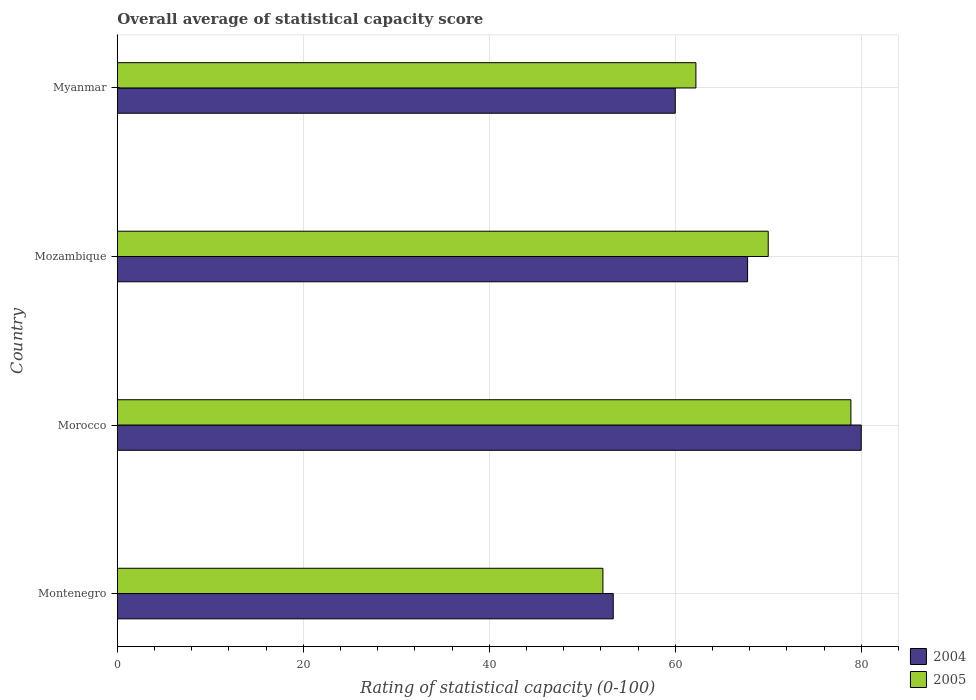How many different coloured bars are there?
Your answer should be very brief. 2. Are the number of bars on each tick of the Y-axis equal?
Give a very brief answer. Yes. How many bars are there on the 3rd tick from the top?
Your answer should be compact. 2. How many bars are there on the 4th tick from the bottom?
Make the answer very short. 2. What is the label of the 1st group of bars from the top?
Provide a short and direct response. Myanmar. In how many cases, is the number of bars for a given country not equal to the number of legend labels?
Ensure brevity in your answer.  0. Across all countries, what is the maximum rating of statistical capacity in 2005?
Provide a short and direct response. 78.89. Across all countries, what is the minimum rating of statistical capacity in 2004?
Your answer should be compact. 53.33. In which country was the rating of statistical capacity in 2004 maximum?
Offer a very short reply. Morocco. In which country was the rating of statistical capacity in 2004 minimum?
Your answer should be very brief. Montenegro. What is the total rating of statistical capacity in 2004 in the graph?
Your response must be concise. 261.11. What is the difference between the rating of statistical capacity in 2005 in Montenegro and that in Myanmar?
Make the answer very short. -10. What is the average rating of statistical capacity in 2004 per country?
Your answer should be compact. 65.28. What is the difference between the rating of statistical capacity in 2005 and rating of statistical capacity in 2004 in Morocco?
Keep it short and to the point. -1.11. In how many countries, is the rating of statistical capacity in 2004 greater than 40 ?
Your response must be concise. 4. What is the ratio of the rating of statistical capacity in 2005 in Morocco to that in Mozambique?
Your response must be concise. 1.13. Is the rating of statistical capacity in 2004 in Montenegro less than that in Morocco?
Ensure brevity in your answer.  Yes. Is the difference between the rating of statistical capacity in 2005 in Montenegro and Myanmar greater than the difference between the rating of statistical capacity in 2004 in Montenegro and Myanmar?
Provide a succinct answer. No. What is the difference between the highest and the second highest rating of statistical capacity in 2005?
Ensure brevity in your answer.  8.89. What is the difference between the highest and the lowest rating of statistical capacity in 2005?
Provide a succinct answer. 26.67. Is the sum of the rating of statistical capacity in 2004 in Montenegro and Mozambique greater than the maximum rating of statistical capacity in 2005 across all countries?
Ensure brevity in your answer.  Yes. What does the 1st bar from the top in Montenegro represents?
Offer a terse response. 2005. How many countries are there in the graph?
Provide a succinct answer. 4. What is the difference between two consecutive major ticks on the X-axis?
Offer a very short reply. 20. Does the graph contain any zero values?
Give a very brief answer. No. How many legend labels are there?
Provide a short and direct response. 2. How are the legend labels stacked?
Make the answer very short. Vertical. What is the title of the graph?
Give a very brief answer. Overall average of statistical capacity score. Does "1962" appear as one of the legend labels in the graph?
Keep it short and to the point. No. What is the label or title of the X-axis?
Offer a terse response. Rating of statistical capacity (0-100). What is the Rating of statistical capacity (0-100) in 2004 in Montenegro?
Your answer should be compact. 53.33. What is the Rating of statistical capacity (0-100) of 2005 in Montenegro?
Provide a succinct answer. 52.22. What is the Rating of statistical capacity (0-100) of 2004 in Morocco?
Ensure brevity in your answer.  80. What is the Rating of statistical capacity (0-100) of 2005 in Morocco?
Keep it short and to the point. 78.89. What is the Rating of statistical capacity (0-100) of 2004 in Mozambique?
Keep it short and to the point. 67.78. What is the Rating of statistical capacity (0-100) in 2004 in Myanmar?
Your answer should be very brief. 60. What is the Rating of statistical capacity (0-100) of 2005 in Myanmar?
Make the answer very short. 62.22. Across all countries, what is the maximum Rating of statistical capacity (0-100) in 2005?
Your response must be concise. 78.89. Across all countries, what is the minimum Rating of statistical capacity (0-100) in 2004?
Your answer should be very brief. 53.33. Across all countries, what is the minimum Rating of statistical capacity (0-100) of 2005?
Make the answer very short. 52.22. What is the total Rating of statistical capacity (0-100) of 2004 in the graph?
Offer a terse response. 261.11. What is the total Rating of statistical capacity (0-100) in 2005 in the graph?
Ensure brevity in your answer.  263.33. What is the difference between the Rating of statistical capacity (0-100) of 2004 in Montenegro and that in Morocco?
Provide a short and direct response. -26.67. What is the difference between the Rating of statistical capacity (0-100) in 2005 in Montenegro and that in Morocco?
Ensure brevity in your answer.  -26.67. What is the difference between the Rating of statistical capacity (0-100) of 2004 in Montenegro and that in Mozambique?
Provide a short and direct response. -14.44. What is the difference between the Rating of statistical capacity (0-100) of 2005 in Montenegro and that in Mozambique?
Offer a very short reply. -17.78. What is the difference between the Rating of statistical capacity (0-100) of 2004 in Montenegro and that in Myanmar?
Your answer should be very brief. -6.67. What is the difference between the Rating of statistical capacity (0-100) in 2005 in Montenegro and that in Myanmar?
Your response must be concise. -10. What is the difference between the Rating of statistical capacity (0-100) of 2004 in Morocco and that in Mozambique?
Give a very brief answer. 12.22. What is the difference between the Rating of statistical capacity (0-100) in 2005 in Morocco and that in Mozambique?
Ensure brevity in your answer.  8.89. What is the difference between the Rating of statistical capacity (0-100) in 2005 in Morocco and that in Myanmar?
Keep it short and to the point. 16.67. What is the difference between the Rating of statistical capacity (0-100) of 2004 in Mozambique and that in Myanmar?
Offer a terse response. 7.78. What is the difference between the Rating of statistical capacity (0-100) of 2005 in Mozambique and that in Myanmar?
Your answer should be compact. 7.78. What is the difference between the Rating of statistical capacity (0-100) of 2004 in Montenegro and the Rating of statistical capacity (0-100) of 2005 in Morocco?
Keep it short and to the point. -25.56. What is the difference between the Rating of statistical capacity (0-100) of 2004 in Montenegro and the Rating of statistical capacity (0-100) of 2005 in Mozambique?
Offer a very short reply. -16.67. What is the difference between the Rating of statistical capacity (0-100) of 2004 in Montenegro and the Rating of statistical capacity (0-100) of 2005 in Myanmar?
Provide a short and direct response. -8.89. What is the difference between the Rating of statistical capacity (0-100) in 2004 in Morocco and the Rating of statistical capacity (0-100) in 2005 in Myanmar?
Offer a very short reply. 17.78. What is the difference between the Rating of statistical capacity (0-100) of 2004 in Mozambique and the Rating of statistical capacity (0-100) of 2005 in Myanmar?
Your answer should be very brief. 5.56. What is the average Rating of statistical capacity (0-100) of 2004 per country?
Your response must be concise. 65.28. What is the average Rating of statistical capacity (0-100) in 2005 per country?
Provide a short and direct response. 65.83. What is the difference between the Rating of statistical capacity (0-100) in 2004 and Rating of statistical capacity (0-100) in 2005 in Montenegro?
Your answer should be compact. 1.11. What is the difference between the Rating of statistical capacity (0-100) of 2004 and Rating of statistical capacity (0-100) of 2005 in Mozambique?
Provide a short and direct response. -2.22. What is the difference between the Rating of statistical capacity (0-100) in 2004 and Rating of statistical capacity (0-100) in 2005 in Myanmar?
Provide a short and direct response. -2.22. What is the ratio of the Rating of statistical capacity (0-100) in 2004 in Montenegro to that in Morocco?
Make the answer very short. 0.67. What is the ratio of the Rating of statistical capacity (0-100) of 2005 in Montenegro to that in Morocco?
Your response must be concise. 0.66. What is the ratio of the Rating of statistical capacity (0-100) of 2004 in Montenegro to that in Mozambique?
Your answer should be very brief. 0.79. What is the ratio of the Rating of statistical capacity (0-100) in 2005 in Montenegro to that in Mozambique?
Your response must be concise. 0.75. What is the ratio of the Rating of statistical capacity (0-100) in 2004 in Montenegro to that in Myanmar?
Ensure brevity in your answer.  0.89. What is the ratio of the Rating of statistical capacity (0-100) in 2005 in Montenegro to that in Myanmar?
Your response must be concise. 0.84. What is the ratio of the Rating of statistical capacity (0-100) of 2004 in Morocco to that in Mozambique?
Offer a terse response. 1.18. What is the ratio of the Rating of statistical capacity (0-100) in 2005 in Morocco to that in Mozambique?
Your response must be concise. 1.13. What is the ratio of the Rating of statistical capacity (0-100) in 2004 in Morocco to that in Myanmar?
Ensure brevity in your answer.  1.33. What is the ratio of the Rating of statistical capacity (0-100) of 2005 in Morocco to that in Myanmar?
Keep it short and to the point. 1.27. What is the ratio of the Rating of statistical capacity (0-100) of 2004 in Mozambique to that in Myanmar?
Provide a short and direct response. 1.13. What is the difference between the highest and the second highest Rating of statistical capacity (0-100) of 2004?
Ensure brevity in your answer.  12.22. What is the difference between the highest and the second highest Rating of statistical capacity (0-100) in 2005?
Make the answer very short. 8.89. What is the difference between the highest and the lowest Rating of statistical capacity (0-100) in 2004?
Your answer should be compact. 26.67. What is the difference between the highest and the lowest Rating of statistical capacity (0-100) in 2005?
Make the answer very short. 26.67. 